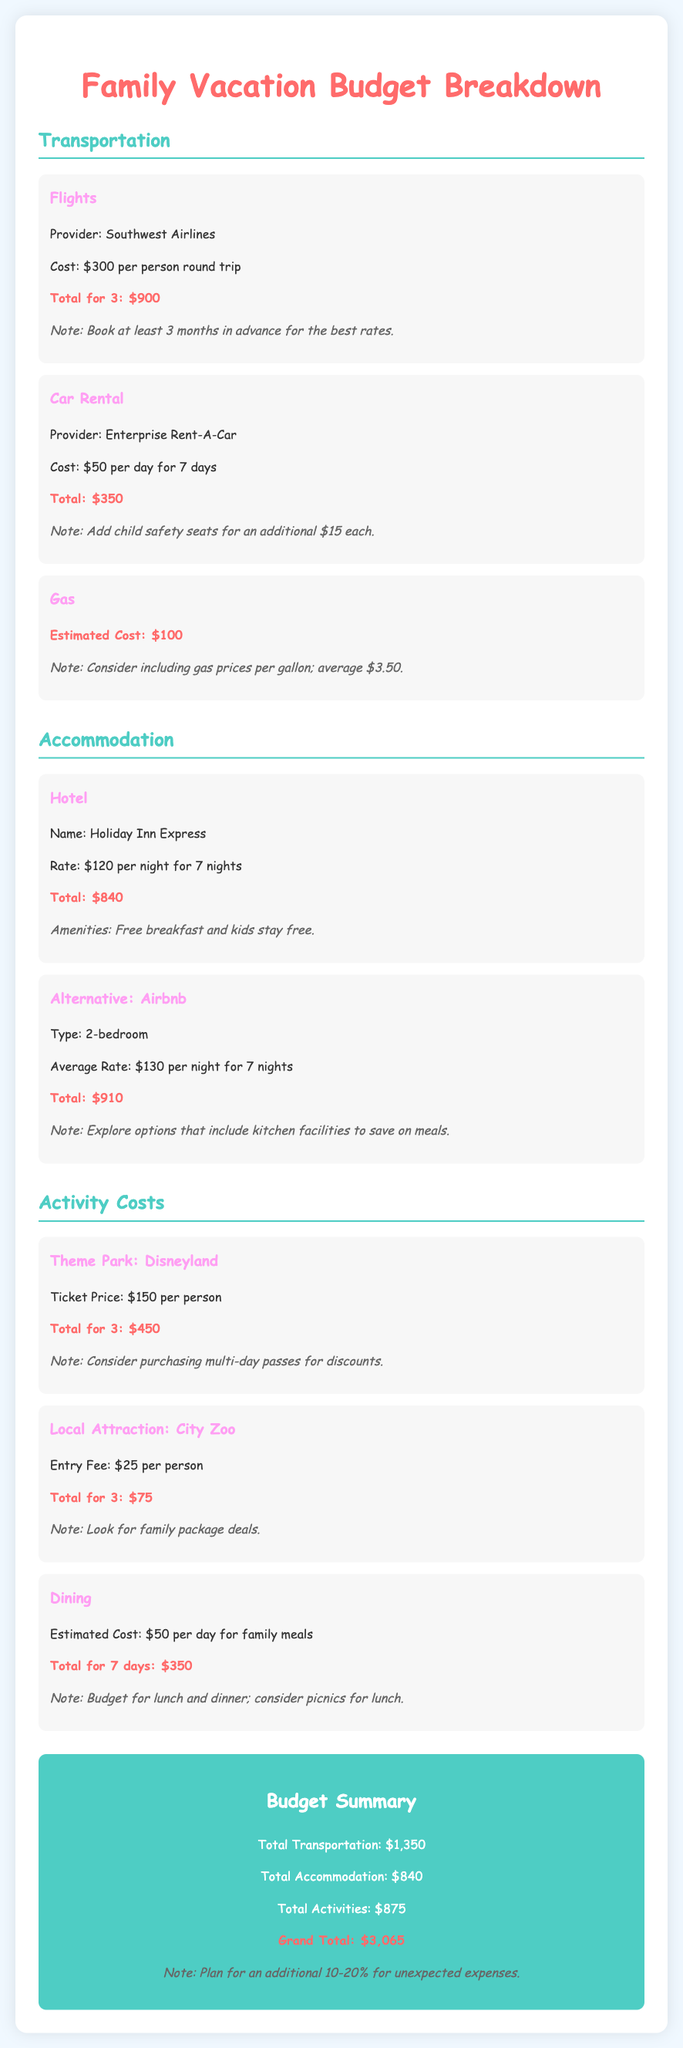What is the cost of flights per person? The document states that the cost of flights is $300 per person round trip.
Answer: $300 What is the total cost for car rental? The total cost for car rental is given as $350 in the transportation section.
Answer: $350 How many nights is the hotel stay? The hotel rate is mentioned for a stay of 7 nights.
Answer: 7 nights What is the ticket price for Disneyland? The document provides that the ticket price for Disneyland is $150 per person.
Answer: $150 What is the total transportation cost? The total transportation cost is found in the budget summary as $1,350.
Answer: $1,350 What is the alternative accommodation mentioned? The alternative accommodation listed is an Airbnb.
Answer: Airbnb What is the total estimated cost for dining over the trip? The total estimated cost for family meals over 7 days is $350.
Answer: $350 What is the grand total for the vacation? The grand total for the vacation is stated as $3,065 in the budget summary.
Answer: $3,065 What is a note regarding booking flights? The document notes to book flights at least 3 months in advance for the best rates.
Answer: Book at least 3 months in advance 